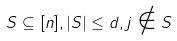<formula> <loc_0><loc_0><loc_500><loc_500>S \subseteq [ n ] , | S | \leq d , j \notin S</formula> 